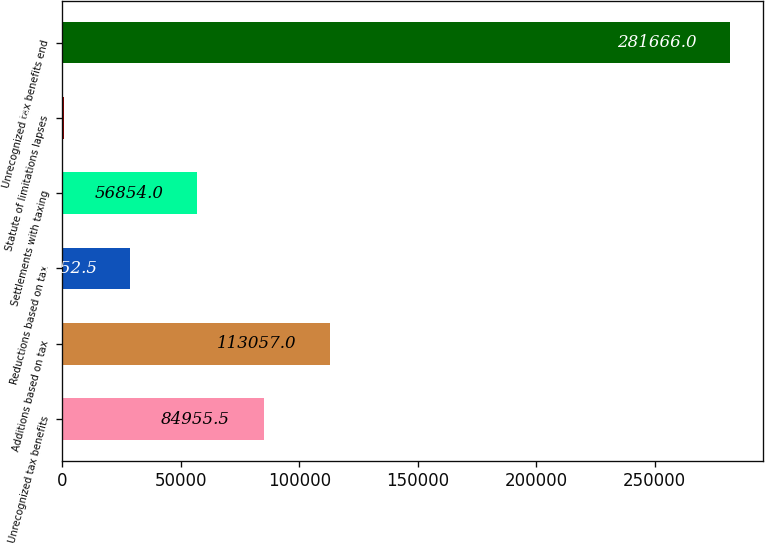<chart> <loc_0><loc_0><loc_500><loc_500><bar_chart><fcel>Unrecognized tax benefits<fcel>Additions based on tax<fcel>Reductions based on tax<fcel>Settlements with taxing<fcel>Statute of limitations lapses<fcel>Unrecognized tax benefits end<nl><fcel>84955.5<fcel>113057<fcel>28752.5<fcel>56854<fcel>651<fcel>281666<nl></chart> 